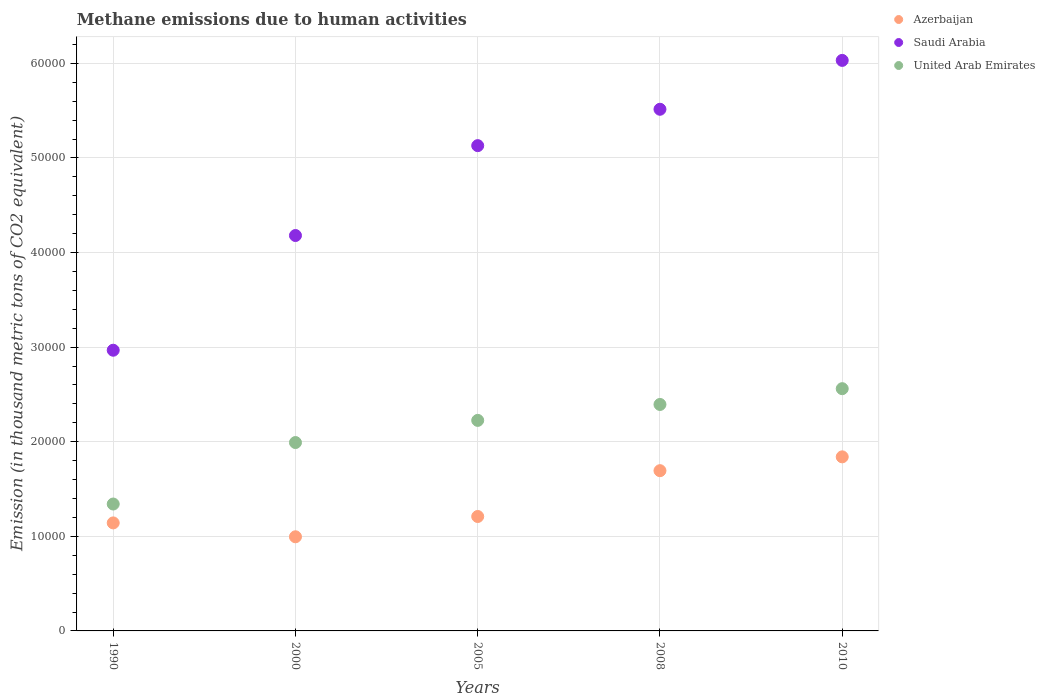How many different coloured dotlines are there?
Ensure brevity in your answer.  3. Is the number of dotlines equal to the number of legend labels?
Your answer should be very brief. Yes. What is the amount of methane emitted in United Arab Emirates in 2000?
Give a very brief answer. 1.99e+04. Across all years, what is the maximum amount of methane emitted in Saudi Arabia?
Offer a very short reply. 6.03e+04. Across all years, what is the minimum amount of methane emitted in Saudi Arabia?
Keep it short and to the point. 2.97e+04. In which year was the amount of methane emitted in United Arab Emirates maximum?
Offer a very short reply. 2010. What is the total amount of methane emitted in United Arab Emirates in the graph?
Ensure brevity in your answer.  1.05e+05. What is the difference between the amount of methane emitted in United Arab Emirates in 1990 and that in 2008?
Make the answer very short. -1.05e+04. What is the difference between the amount of methane emitted in United Arab Emirates in 2005 and the amount of methane emitted in Saudi Arabia in 2000?
Ensure brevity in your answer.  -1.95e+04. What is the average amount of methane emitted in United Arab Emirates per year?
Your answer should be very brief. 2.10e+04. In the year 2000, what is the difference between the amount of methane emitted in United Arab Emirates and amount of methane emitted in Azerbaijan?
Offer a very short reply. 9962.3. In how many years, is the amount of methane emitted in Saudi Arabia greater than 34000 thousand metric tons?
Provide a short and direct response. 4. What is the ratio of the amount of methane emitted in United Arab Emirates in 2005 to that in 2010?
Provide a short and direct response. 0.87. Is the difference between the amount of methane emitted in United Arab Emirates in 1990 and 2010 greater than the difference between the amount of methane emitted in Azerbaijan in 1990 and 2010?
Provide a succinct answer. No. What is the difference between the highest and the second highest amount of methane emitted in Azerbaijan?
Your answer should be very brief. 1461.4. What is the difference between the highest and the lowest amount of methane emitted in Saudi Arabia?
Make the answer very short. 3.06e+04. In how many years, is the amount of methane emitted in Saudi Arabia greater than the average amount of methane emitted in Saudi Arabia taken over all years?
Provide a short and direct response. 3. How many dotlines are there?
Keep it short and to the point. 3. How many years are there in the graph?
Your response must be concise. 5. What is the difference between two consecutive major ticks on the Y-axis?
Offer a terse response. 10000. Are the values on the major ticks of Y-axis written in scientific E-notation?
Offer a terse response. No. Does the graph contain any zero values?
Offer a terse response. No. Does the graph contain grids?
Keep it short and to the point. Yes. Where does the legend appear in the graph?
Your answer should be compact. Top right. How many legend labels are there?
Give a very brief answer. 3. How are the legend labels stacked?
Provide a succinct answer. Vertical. What is the title of the graph?
Offer a very short reply. Methane emissions due to human activities. Does "Djibouti" appear as one of the legend labels in the graph?
Provide a short and direct response. No. What is the label or title of the X-axis?
Your answer should be compact. Years. What is the label or title of the Y-axis?
Provide a succinct answer. Emission (in thousand metric tons of CO2 equivalent). What is the Emission (in thousand metric tons of CO2 equivalent) in Azerbaijan in 1990?
Give a very brief answer. 1.14e+04. What is the Emission (in thousand metric tons of CO2 equivalent) of Saudi Arabia in 1990?
Give a very brief answer. 2.97e+04. What is the Emission (in thousand metric tons of CO2 equivalent) in United Arab Emirates in 1990?
Offer a very short reply. 1.34e+04. What is the Emission (in thousand metric tons of CO2 equivalent) in Azerbaijan in 2000?
Provide a short and direct response. 9950.9. What is the Emission (in thousand metric tons of CO2 equivalent) in Saudi Arabia in 2000?
Your response must be concise. 4.18e+04. What is the Emission (in thousand metric tons of CO2 equivalent) of United Arab Emirates in 2000?
Offer a very short reply. 1.99e+04. What is the Emission (in thousand metric tons of CO2 equivalent) in Azerbaijan in 2005?
Offer a terse response. 1.21e+04. What is the Emission (in thousand metric tons of CO2 equivalent) in Saudi Arabia in 2005?
Provide a succinct answer. 5.13e+04. What is the Emission (in thousand metric tons of CO2 equivalent) of United Arab Emirates in 2005?
Ensure brevity in your answer.  2.23e+04. What is the Emission (in thousand metric tons of CO2 equivalent) of Azerbaijan in 2008?
Offer a very short reply. 1.69e+04. What is the Emission (in thousand metric tons of CO2 equivalent) of Saudi Arabia in 2008?
Offer a terse response. 5.51e+04. What is the Emission (in thousand metric tons of CO2 equivalent) of United Arab Emirates in 2008?
Ensure brevity in your answer.  2.39e+04. What is the Emission (in thousand metric tons of CO2 equivalent) of Azerbaijan in 2010?
Offer a terse response. 1.84e+04. What is the Emission (in thousand metric tons of CO2 equivalent) in Saudi Arabia in 2010?
Offer a terse response. 6.03e+04. What is the Emission (in thousand metric tons of CO2 equivalent) of United Arab Emirates in 2010?
Keep it short and to the point. 2.56e+04. Across all years, what is the maximum Emission (in thousand metric tons of CO2 equivalent) in Azerbaijan?
Provide a short and direct response. 1.84e+04. Across all years, what is the maximum Emission (in thousand metric tons of CO2 equivalent) of Saudi Arabia?
Provide a succinct answer. 6.03e+04. Across all years, what is the maximum Emission (in thousand metric tons of CO2 equivalent) in United Arab Emirates?
Give a very brief answer. 2.56e+04. Across all years, what is the minimum Emission (in thousand metric tons of CO2 equivalent) in Azerbaijan?
Keep it short and to the point. 9950.9. Across all years, what is the minimum Emission (in thousand metric tons of CO2 equivalent) of Saudi Arabia?
Your response must be concise. 2.97e+04. Across all years, what is the minimum Emission (in thousand metric tons of CO2 equivalent) of United Arab Emirates?
Ensure brevity in your answer.  1.34e+04. What is the total Emission (in thousand metric tons of CO2 equivalent) of Azerbaijan in the graph?
Your response must be concise. 6.88e+04. What is the total Emission (in thousand metric tons of CO2 equivalent) of Saudi Arabia in the graph?
Your answer should be very brief. 2.38e+05. What is the total Emission (in thousand metric tons of CO2 equivalent) of United Arab Emirates in the graph?
Your answer should be very brief. 1.05e+05. What is the difference between the Emission (in thousand metric tons of CO2 equivalent) in Azerbaijan in 1990 and that in 2000?
Provide a succinct answer. 1467.3. What is the difference between the Emission (in thousand metric tons of CO2 equivalent) of Saudi Arabia in 1990 and that in 2000?
Keep it short and to the point. -1.21e+04. What is the difference between the Emission (in thousand metric tons of CO2 equivalent) in United Arab Emirates in 1990 and that in 2000?
Make the answer very short. -6499. What is the difference between the Emission (in thousand metric tons of CO2 equivalent) of Azerbaijan in 1990 and that in 2005?
Ensure brevity in your answer.  -678.1. What is the difference between the Emission (in thousand metric tons of CO2 equivalent) in Saudi Arabia in 1990 and that in 2005?
Offer a terse response. -2.16e+04. What is the difference between the Emission (in thousand metric tons of CO2 equivalent) of United Arab Emirates in 1990 and that in 2005?
Your answer should be compact. -8841.4. What is the difference between the Emission (in thousand metric tons of CO2 equivalent) of Azerbaijan in 1990 and that in 2008?
Offer a very short reply. -5520.9. What is the difference between the Emission (in thousand metric tons of CO2 equivalent) of Saudi Arabia in 1990 and that in 2008?
Ensure brevity in your answer.  -2.55e+04. What is the difference between the Emission (in thousand metric tons of CO2 equivalent) of United Arab Emirates in 1990 and that in 2008?
Provide a succinct answer. -1.05e+04. What is the difference between the Emission (in thousand metric tons of CO2 equivalent) in Azerbaijan in 1990 and that in 2010?
Provide a succinct answer. -6982.3. What is the difference between the Emission (in thousand metric tons of CO2 equivalent) in Saudi Arabia in 1990 and that in 2010?
Your answer should be compact. -3.06e+04. What is the difference between the Emission (in thousand metric tons of CO2 equivalent) of United Arab Emirates in 1990 and that in 2010?
Keep it short and to the point. -1.22e+04. What is the difference between the Emission (in thousand metric tons of CO2 equivalent) in Azerbaijan in 2000 and that in 2005?
Your answer should be compact. -2145.4. What is the difference between the Emission (in thousand metric tons of CO2 equivalent) of Saudi Arabia in 2000 and that in 2005?
Make the answer very short. -9501.6. What is the difference between the Emission (in thousand metric tons of CO2 equivalent) of United Arab Emirates in 2000 and that in 2005?
Offer a very short reply. -2342.4. What is the difference between the Emission (in thousand metric tons of CO2 equivalent) of Azerbaijan in 2000 and that in 2008?
Give a very brief answer. -6988.2. What is the difference between the Emission (in thousand metric tons of CO2 equivalent) in Saudi Arabia in 2000 and that in 2008?
Your answer should be very brief. -1.33e+04. What is the difference between the Emission (in thousand metric tons of CO2 equivalent) of United Arab Emirates in 2000 and that in 2008?
Ensure brevity in your answer.  -4025.9. What is the difference between the Emission (in thousand metric tons of CO2 equivalent) of Azerbaijan in 2000 and that in 2010?
Offer a terse response. -8449.6. What is the difference between the Emission (in thousand metric tons of CO2 equivalent) in Saudi Arabia in 2000 and that in 2010?
Offer a terse response. -1.85e+04. What is the difference between the Emission (in thousand metric tons of CO2 equivalent) in United Arab Emirates in 2000 and that in 2010?
Provide a short and direct response. -5694.4. What is the difference between the Emission (in thousand metric tons of CO2 equivalent) of Azerbaijan in 2005 and that in 2008?
Your answer should be compact. -4842.8. What is the difference between the Emission (in thousand metric tons of CO2 equivalent) of Saudi Arabia in 2005 and that in 2008?
Your answer should be compact. -3844.6. What is the difference between the Emission (in thousand metric tons of CO2 equivalent) in United Arab Emirates in 2005 and that in 2008?
Make the answer very short. -1683.5. What is the difference between the Emission (in thousand metric tons of CO2 equivalent) in Azerbaijan in 2005 and that in 2010?
Provide a succinct answer. -6304.2. What is the difference between the Emission (in thousand metric tons of CO2 equivalent) of Saudi Arabia in 2005 and that in 2010?
Provide a succinct answer. -9011.1. What is the difference between the Emission (in thousand metric tons of CO2 equivalent) in United Arab Emirates in 2005 and that in 2010?
Ensure brevity in your answer.  -3352. What is the difference between the Emission (in thousand metric tons of CO2 equivalent) of Azerbaijan in 2008 and that in 2010?
Give a very brief answer. -1461.4. What is the difference between the Emission (in thousand metric tons of CO2 equivalent) of Saudi Arabia in 2008 and that in 2010?
Your response must be concise. -5166.5. What is the difference between the Emission (in thousand metric tons of CO2 equivalent) of United Arab Emirates in 2008 and that in 2010?
Your answer should be very brief. -1668.5. What is the difference between the Emission (in thousand metric tons of CO2 equivalent) of Azerbaijan in 1990 and the Emission (in thousand metric tons of CO2 equivalent) of Saudi Arabia in 2000?
Your response must be concise. -3.04e+04. What is the difference between the Emission (in thousand metric tons of CO2 equivalent) in Azerbaijan in 1990 and the Emission (in thousand metric tons of CO2 equivalent) in United Arab Emirates in 2000?
Offer a terse response. -8495. What is the difference between the Emission (in thousand metric tons of CO2 equivalent) in Saudi Arabia in 1990 and the Emission (in thousand metric tons of CO2 equivalent) in United Arab Emirates in 2000?
Your answer should be compact. 9758.9. What is the difference between the Emission (in thousand metric tons of CO2 equivalent) of Azerbaijan in 1990 and the Emission (in thousand metric tons of CO2 equivalent) of Saudi Arabia in 2005?
Give a very brief answer. -3.99e+04. What is the difference between the Emission (in thousand metric tons of CO2 equivalent) of Azerbaijan in 1990 and the Emission (in thousand metric tons of CO2 equivalent) of United Arab Emirates in 2005?
Give a very brief answer. -1.08e+04. What is the difference between the Emission (in thousand metric tons of CO2 equivalent) of Saudi Arabia in 1990 and the Emission (in thousand metric tons of CO2 equivalent) of United Arab Emirates in 2005?
Offer a very short reply. 7416.5. What is the difference between the Emission (in thousand metric tons of CO2 equivalent) of Azerbaijan in 1990 and the Emission (in thousand metric tons of CO2 equivalent) of Saudi Arabia in 2008?
Ensure brevity in your answer.  -4.37e+04. What is the difference between the Emission (in thousand metric tons of CO2 equivalent) of Azerbaijan in 1990 and the Emission (in thousand metric tons of CO2 equivalent) of United Arab Emirates in 2008?
Your answer should be very brief. -1.25e+04. What is the difference between the Emission (in thousand metric tons of CO2 equivalent) of Saudi Arabia in 1990 and the Emission (in thousand metric tons of CO2 equivalent) of United Arab Emirates in 2008?
Your response must be concise. 5733. What is the difference between the Emission (in thousand metric tons of CO2 equivalent) of Azerbaijan in 1990 and the Emission (in thousand metric tons of CO2 equivalent) of Saudi Arabia in 2010?
Make the answer very short. -4.89e+04. What is the difference between the Emission (in thousand metric tons of CO2 equivalent) in Azerbaijan in 1990 and the Emission (in thousand metric tons of CO2 equivalent) in United Arab Emirates in 2010?
Your response must be concise. -1.42e+04. What is the difference between the Emission (in thousand metric tons of CO2 equivalent) in Saudi Arabia in 1990 and the Emission (in thousand metric tons of CO2 equivalent) in United Arab Emirates in 2010?
Provide a short and direct response. 4064.5. What is the difference between the Emission (in thousand metric tons of CO2 equivalent) in Azerbaijan in 2000 and the Emission (in thousand metric tons of CO2 equivalent) in Saudi Arabia in 2005?
Keep it short and to the point. -4.13e+04. What is the difference between the Emission (in thousand metric tons of CO2 equivalent) in Azerbaijan in 2000 and the Emission (in thousand metric tons of CO2 equivalent) in United Arab Emirates in 2005?
Ensure brevity in your answer.  -1.23e+04. What is the difference between the Emission (in thousand metric tons of CO2 equivalent) of Saudi Arabia in 2000 and the Emission (in thousand metric tons of CO2 equivalent) of United Arab Emirates in 2005?
Make the answer very short. 1.95e+04. What is the difference between the Emission (in thousand metric tons of CO2 equivalent) in Azerbaijan in 2000 and the Emission (in thousand metric tons of CO2 equivalent) in Saudi Arabia in 2008?
Your response must be concise. -4.52e+04. What is the difference between the Emission (in thousand metric tons of CO2 equivalent) in Azerbaijan in 2000 and the Emission (in thousand metric tons of CO2 equivalent) in United Arab Emirates in 2008?
Keep it short and to the point. -1.40e+04. What is the difference between the Emission (in thousand metric tons of CO2 equivalent) of Saudi Arabia in 2000 and the Emission (in thousand metric tons of CO2 equivalent) of United Arab Emirates in 2008?
Offer a terse response. 1.79e+04. What is the difference between the Emission (in thousand metric tons of CO2 equivalent) of Azerbaijan in 2000 and the Emission (in thousand metric tons of CO2 equivalent) of Saudi Arabia in 2010?
Keep it short and to the point. -5.04e+04. What is the difference between the Emission (in thousand metric tons of CO2 equivalent) of Azerbaijan in 2000 and the Emission (in thousand metric tons of CO2 equivalent) of United Arab Emirates in 2010?
Offer a very short reply. -1.57e+04. What is the difference between the Emission (in thousand metric tons of CO2 equivalent) in Saudi Arabia in 2000 and the Emission (in thousand metric tons of CO2 equivalent) in United Arab Emirates in 2010?
Your answer should be compact. 1.62e+04. What is the difference between the Emission (in thousand metric tons of CO2 equivalent) in Azerbaijan in 2005 and the Emission (in thousand metric tons of CO2 equivalent) in Saudi Arabia in 2008?
Make the answer very short. -4.30e+04. What is the difference between the Emission (in thousand metric tons of CO2 equivalent) in Azerbaijan in 2005 and the Emission (in thousand metric tons of CO2 equivalent) in United Arab Emirates in 2008?
Provide a short and direct response. -1.18e+04. What is the difference between the Emission (in thousand metric tons of CO2 equivalent) of Saudi Arabia in 2005 and the Emission (in thousand metric tons of CO2 equivalent) of United Arab Emirates in 2008?
Your response must be concise. 2.74e+04. What is the difference between the Emission (in thousand metric tons of CO2 equivalent) of Azerbaijan in 2005 and the Emission (in thousand metric tons of CO2 equivalent) of Saudi Arabia in 2010?
Your response must be concise. -4.82e+04. What is the difference between the Emission (in thousand metric tons of CO2 equivalent) of Azerbaijan in 2005 and the Emission (in thousand metric tons of CO2 equivalent) of United Arab Emirates in 2010?
Your answer should be very brief. -1.35e+04. What is the difference between the Emission (in thousand metric tons of CO2 equivalent) of Saudi Arabia in 2005 and the Emission (in thousand metric tons of CO2 equivalent) of United Arab Emirates in 2010?
Make the answer very short. 2.57e+04. What is the difference between the Emission (in thousand metric tons of CO2 equivalent) in Azerbaijan in 2008 and the Emission (in thousand metric tons of CO2 equivalent) in Saudi Arabia in 2010?
Provide a short and direct response. -4.34e+04. What is the difference between the Emission (in thousand metric tons of CO2 equivalent) of Azerbaijan in 2008 and the Emission (in thousand metric tons of CO2 equivalent) of United Arab Emirates in 2010?
Provide a short and direct response. -8668.5. What is the difference between the Emission (in thousand metric tons of CO2 equivalent) of Saudi Arabia in 2008 and the Emission (in thousand metric tons of CO2 equivalent) of United Arab Emirates in 2010?
Your answer should be compact. 2.95e+04. What is the average Emission (in thousand metric tons of CO2 equivalent) in Azerbaijan per year?
Your response must be concise. 1.38e+04. What is the average Emission (in thousand metric tons of CO2 equivalent) in Saudi Arabia per year?
Ensure brevity in your answer.  4.76e+04. What is the average Emission (in thousand metric tons of CO2 equivalent) in United Arab Emirates per year?
Your answer should be very brief. 2.10e+04. In the year 1990, what is the difference between the Emission (in thousand metric tons of CO2 equivalent) in Azerbaijan and Emission (in thousand metric tons of CO2 equivalent) in Saudi Arabia?
Your answer should be very brief. -1.83e+04. In the year 1990, what is the difference between the Emission (in thousand metric tons of CO2 equivalent) of Azerbaijan and Emission (in thousand metric tons of CO2 equivalent) of United Arab Emirates?
Offer a terse response. -1996. In the year 1990, what is the difference between the Emission (in thousand metric tons of CO2 equivalent) in Saudi Arabia and Emission (in thousand metric tons of CO2 equivalent) in United Arab Emirates?
Provide a succinct answer. 1.63e+04. In the year 2000, what is the difference between the Emission (in thousand metric tons of CO2 equivalent) in Azerbaijan and Emission (in thousand metric tons of CO2 equivalent) in Saudi Arabia?
Your answer should be very brief. -3.18e+04. In the year 2000, what is the difference between the Emission (in thousand metric tons of CO2 equivalent) of Azerbaijan and Emission (in thousand metric tons of CO2 equivalent) of United Arab Emirates?
Keep it short and to the point. -9962.3. In the year 2000, what is the difference between the Emission (in thousand metric tons of CO2 equivalent) in Saudi Arabia and Emission (in thousand metric tons of CO2 equivalent) in United Arab Emirates?
Your response must be concise. 2.19e+04. In the year 2005, what is the difference between the Emission (in thousand metric tons of CO2 equivalent) in Azerbaijan and Emission (in thousand metric tons of CO2 equivalent) in Saudi Arabia?
Your answer should be very brief. -3.92e+04. In the year 2005, what is the difference between the Emission (in thousand metric tons of CO2 equivalent) of Azerbaijan and Emission (in thousand metric tons of CO2 equivalent) of United Arab Emirates?
Provide a succinct answer. -1.02e+04. In the year 2005, what is the difference between the Emission (in thousand metric tons of CO2 equivalent) of Saudi Arabia and Emission (in thousand metric tons of CO2 equivalent) of United Arab Emirates?
Ensure brevity in your answer.  2.90e+04. In the year 2008, what is the difference between the Emission (in thousand metric tons of CO2 equivalent) in Azerbaijan and Emission (in thousand metric tons of CO2 equivalent) in Saudi Arabia?
Offer a very short reply. -3.82e+04. In the year 2008, what is the difference between the Emission (in thousand metric tons of CO2 equivalent) of Azerbaijan and Emission (in thousand metric tons of CO2 equivalent) of United Arab Emirates?
Give a very brief answer. -7000. In the year 2008, what is the difference between the Emission (in thousand metric tons of CO2 equivalent) of Saudi Arabia and Emission (in thousand metric tons of CO2 equivalent) of United Arab Emirates?
Your answer should be compact. 3.12e+04. In the year 2010, what is the difference between the Emission (in thousand metric tons of CO2 equivalent) of Azerbaijan and Emission (in thousand metric tons of CO2 equivalent) of Saudi Arabia?
Provide a succinct answer. -4.19e+04. In the year 2010, what is the difference between the Emission (in thousand metric tons of CO2 equivalent) of Azerbaijan and Emission (in thousand metric tons of CO2 equivalent) of United Arab Emirates?
Your answer should be very brief. -7207.1. In the year 2010, what is the difference between the Emission (in thousand metric tons of CO2 equivalent) in Saudi Arabia and Emission (in thousand metric tons of CO2 equivalent) in United Arab Emirates?
Give a very brief answer. 3.47e+04. What is the ratio of the Emission (in thousand metric tons of CO2 equivalent) in Azerbaijan in 1990 to that in 2000?
Your answer should be compact. 1.15. What is the ratio of the Emission (in thousand metric tons of CO2 equivalent) in Saudi Arabia in 1990 to that in 2000?
Provide a short and direct response. 0.71. What is the ratio of the Emission (in thousand metric tons of CO2 equivalent) of United Arab Emirates in 1990 to that in 2000?
Your response must be concise. 0.67. What is the ratio of the Emission (in thousand metric tons of CO2 equivalent) in Azerbaijan in 1990 to that in 2005?
Keep it short and to the point. 0.94. What is the ratio of the Emission (in thousand metric tons of CO2 equivalent) of Saudi Arabia in 1990 to that in 2005?
Your response must be concise. 0.58. What is the ratio of the Emission (in thousand metric tons of CO2 equivalent) in United Arab Emirates in 1990 to that in 2005?
Make the answer very short. 0.6. What is the ratio of the Emission (in thousand metric tons of CO2 equivalent) in Azerbaijan in 1990 to that in 2008?
Your response must be concise. 0.67. What is the ratio of the Emission (in thousand metric tons of CO2 equivalent) of Saudi Arabia in 1990 to that in 2008?
Provide a short and direct response. 0.54. What is the ratio of the Emission (in thousand metric tons of CO2 equivalent) of United Arab Emirates in 1990 to that in 2008?
Ensure brevity in your answer.  0.56. What is the ratio of the Emission (in thousand metric tons of CO2 equivalent) of Azerbaijan in 1990 to that in 2010?
Make the answer very short. 0.62. What is the ratio of the Emission (in thousand metric tons of CO2 equivalent) in Saudi Arabia in 1990 to that in 2010?
Your answer should be compact. 0.49. What is the ratio of the Emission (in thousand metric tons of CO2 equivalent) of United Arab Emirates in 1990 to that in 2010?
Keep it short and to the point. 0.52. What is the ratio of the Emission (in thousand metric tons of CO2 equivalent) of Azerbaijan in 2000 to that in 2005?
Your answer should be very brief. 0.82. What is the ratio of the Emission (in thousand metric tons of CO2 equivalent) of Saudi Arabia in 2000 to that in 2005?
Provide a short and direct response. 0.81. What is the ratio of the Emission (in thousand metric tons of CO2 equivalent) of United Arab Emirates in 2000 to that in 2005?
Offer a terse response. 0.89. What is the ratio of the Emission (in thousand metric tons of CO2 equivalent) in Azerbaijan in 2000 to that in 2008?
Offer a terse response. 0.59. What is the ratio of the Emission (in thousand metric tons of CO2 equivalent) in Saudi Arabia in 2000 to that in 2008?
Your answer should be very brief. 0.76. What is the ratio of the Emission (in thousand metric tons of CO2 equivalent) in United Arab Emirates in 2000 to that in 2008?
Provide a succinct answer. 0.83. What is the ratio of the Emission (in thousand metric tons of CO2 equivalent) in Azerbaijan in 2000 to that in 2010?
Offer a very short reply. 0.54. What is the ratio of the Emission (in thousand metric tons of CO2 equivalent) of Saudi Arabia in 2000 to that in 2010?
Your answer should be compact. 0.69. What is the ratio of the Emission (in thousand metric tons of CO2 equivalent) in United Arab Emirates in 2000 to that in 2010?
Give a very brief answer. 0.78. What is the ratio of the Emission (in thousand metric tons of CO2 equivalent) of Azerbaijan in 2005 to that in 2008?
Ensure brevity in your answer.  0.71. What is the ratio of the Emission (in thousand metric tons of CO2 equivalent) in Saudi Arabia in 2005 to that in 2008?
Give a very brief answer. 0.93. What is the ratio of the Emission (in thousand metric tons of CO2 equivalent) in United Arab Emirates in 2005 to that in 2008?
Ensure brevity in your answer.  0.93. What is the ratio of the Emission (in thousand metric tons of CO2 equivalent) in Azerbaijan in 2005 to that in 2010?
Make the answer very short. 0.66. What is the ratio of the Emission (in thousand metric tons of CO2 equivalent) in Saudi Arabia in 2005 to that in 2010?
Your response must be concise. 0.85. What is the ratio of the Emission (in thousand metric tons of CO2 equivalent) of United Arab Emirates in 2005 to that in 2010?
Provide a short and direct response. 0.87. What is the ratio of the Emission (in thousand metric tons of CO2 equivalent) of Azerbaijan in 2008 to that in 2010?
Keep it short and to the point. 0.92. What is the ratio of the Emission (in thousand metric tons of CO2 equivalent) in Saudi Arabia in 2008 to that in 2010?
Keep it short and to the point. 0.91. What is the ratio of the Emission (in thousand metric tons of CO2 equivalent) of United Arab Emirates in 2008 to that in 2010?
Offer a terse response. 0.93. What is the difference between the highest and the second highest Emission (in thousand metric tons of CO2 equivalent) in Azerbaijan?
Provide a short and direct response. 1461.4. What is the difference between the highest and the second highest Emission (in thousand metric tons of CO2 equivalent) of Saudi Arabia?
Provide a succinct answer. 5166.5. What is the difference between the highest and the second highest Emission (in thousand metric tons of CO2 equivalent) of United Arab Emirates?
Offer a terse response. 1668.5. What is the difference between the highest and the lowest Emission (in thousand metric tons of CO2 equivalent) of Azerbaijan?
Provide a succinct answer. 8449.6. What is the difference between the highest and the lowest Emission (in thousand metric tons of CO2 equivalent) of Saudi Arabia?
Your answer should be compact. 3.06e+04. What is the difference between the highest and the lowest Emission (in thousand metric tons of CO2 equivalent) in United Arab Emirates?
Your answer should be very brief. 1.22e+04. 